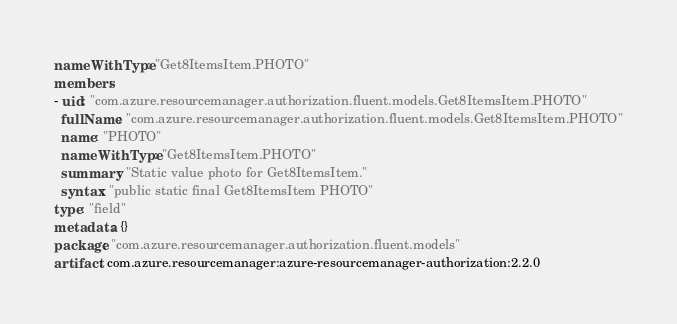<code> <loc_0><loc_0><loc_500><loc_500><_YAML_>nameWithType: "Get8ItemsItem.PHOTO"
members:
- uid: "com.azure.resourcemanager.authorization.fluent.models.Get8ItemsItem.PHOTO"
  fullName: "com.azure.resourcemanager.authorization.fluent.models.Get8ItemsItem.PHOTO"
  name: "PHOTO"
  nameWithType: "Get8ItemsItem.PHOTO"
  summary: "Static value photo for Get8ItemsItem."
  syntax: "public static final Get8ItemsItem PHOTO"
type: "field"
metadata: {}
package: "com.azure.resourcemanager.authorization.fluent.models"
artifact: com.azure.resourcemanager:azure-resourcemanager-authorization:2.2.0
</code> 